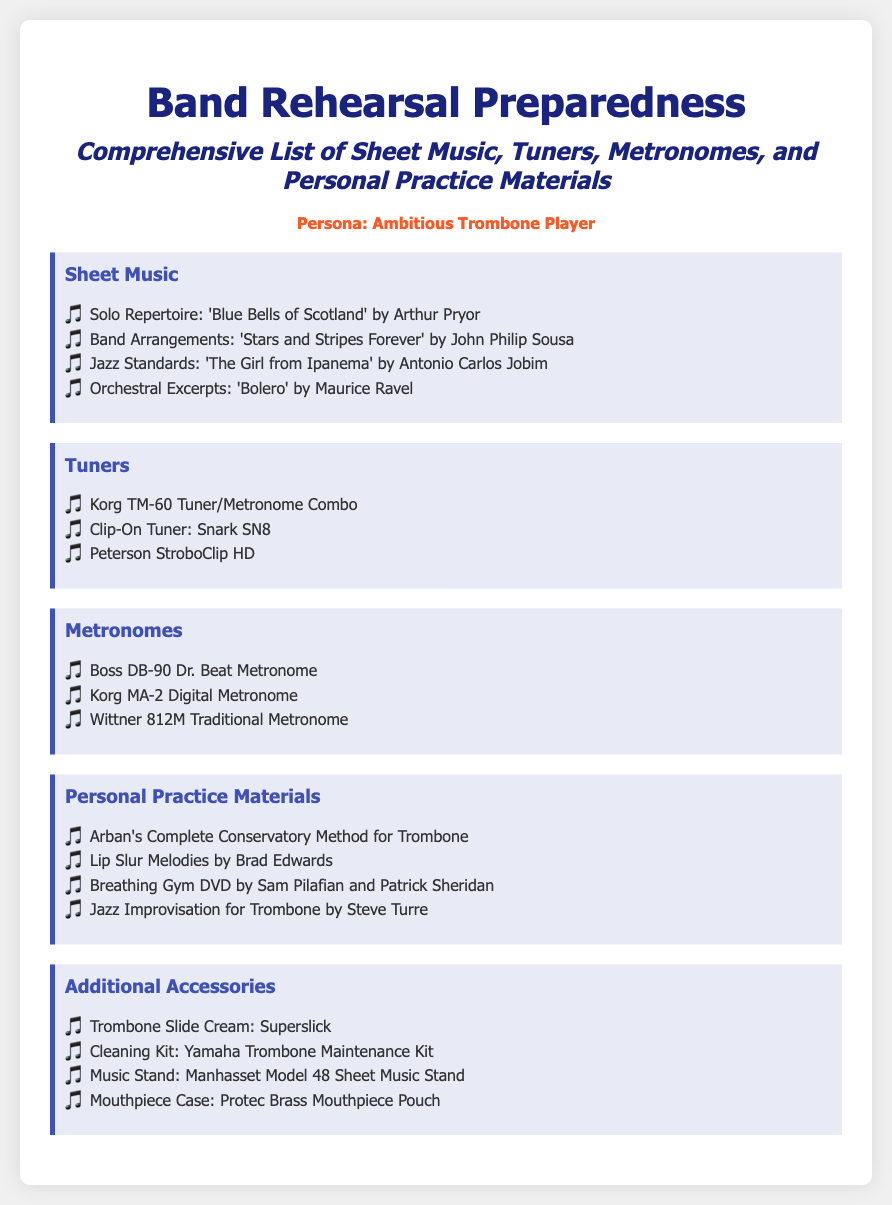What is the title of the solo repertoire? The title of the solo repertoire mentioned is 'Blue Bells of Scotland' by Arthur Pryor.
Answer: 'Blue Bells of Scotland' How many tuners are listed? The document lists three tuners under the Tuners category.
Answer: 3 Which piece is included as a band arrangement? The band arrangement included is 'Stars and Stripes Forever' by John Philip Sousa.
Answer: 'Stars and Stripes Forever' What is one of the personal practice materials? One of the personal practice materials listed is 'Arban's Complete Conservatory Method for Trombone.'
Answer: 'Arban's Complete Conservatory Method for Trombone' What accessory is mentioned for trombone maintenance? The document mentions 'Superslick' as the trombone slide cream for maintenance.
Answer: Superslick Which metronome model is the first listed? The first metronome model listed is Boss DB-90 Dr. Beat Metronome.
Answer: Boss DB-90 Dr. Beat Metronome What is the color of the container background? The background color of the container is white, as seen in the document's style.
Answer: white How are the sheet music items represented in the list? The sheet music items are represented as bullet points which begin with a musical note emoji.
Answer: bullet points 